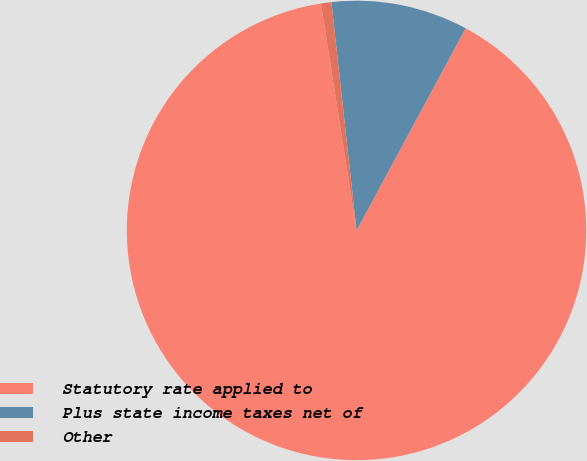<chart> <loc_0><loc_0><loc_500><loc_500><pie_chart><fcel>Statutory rate applied to<fcel>Plus state income taxes net of<fcel>Other<nl><fcel>89.64%<fcel>9.62%<fcel>0.73%<nl></chart> 